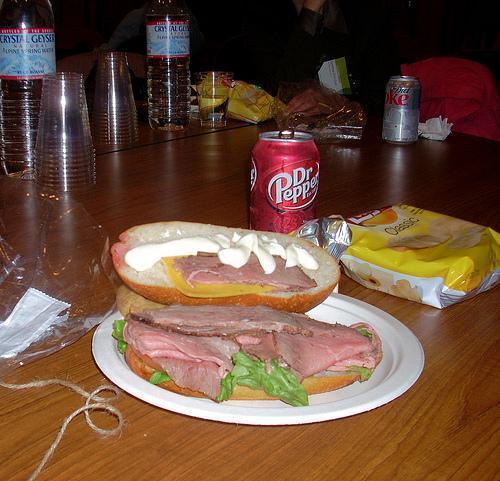How many cups are there?
Give a very brief answer. 3. How many ties is the man wearing?
Give a very brief answer. 0. 